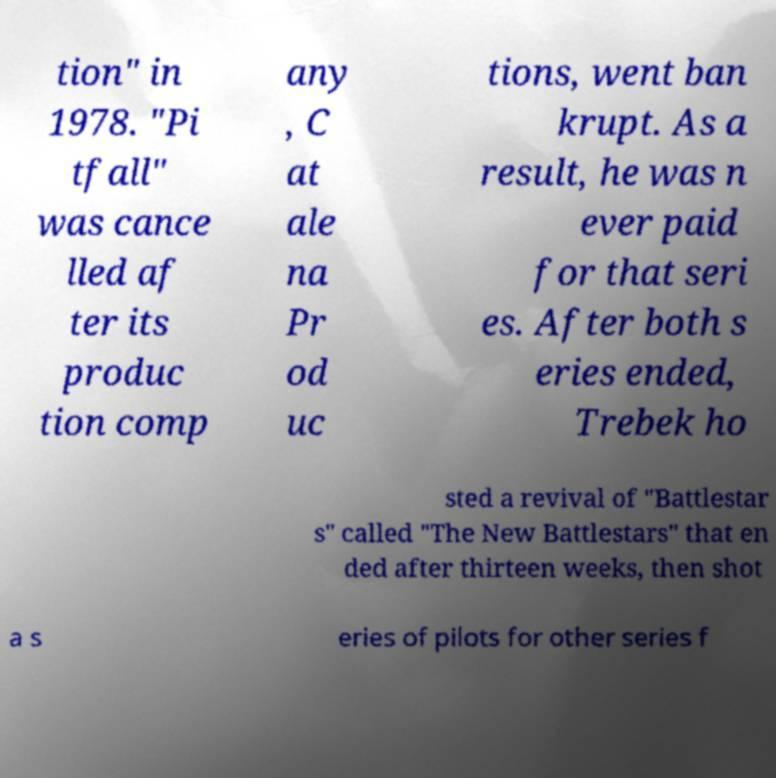I need the written content from this picture converted into text. Can you do that? tion" in 1978. "Pi tfall" was cance lled af ter its produc tion comp any , C at ale na Pr od uc tions, went ban krupt. As a result, he was n ever paid for that seri es. After both s eries ended, Trebek ho sted a revival of "Battlestar s" called "The New Battlestars" that en ded after thirteen weeks, then shot a s eries of pilots for other series f 